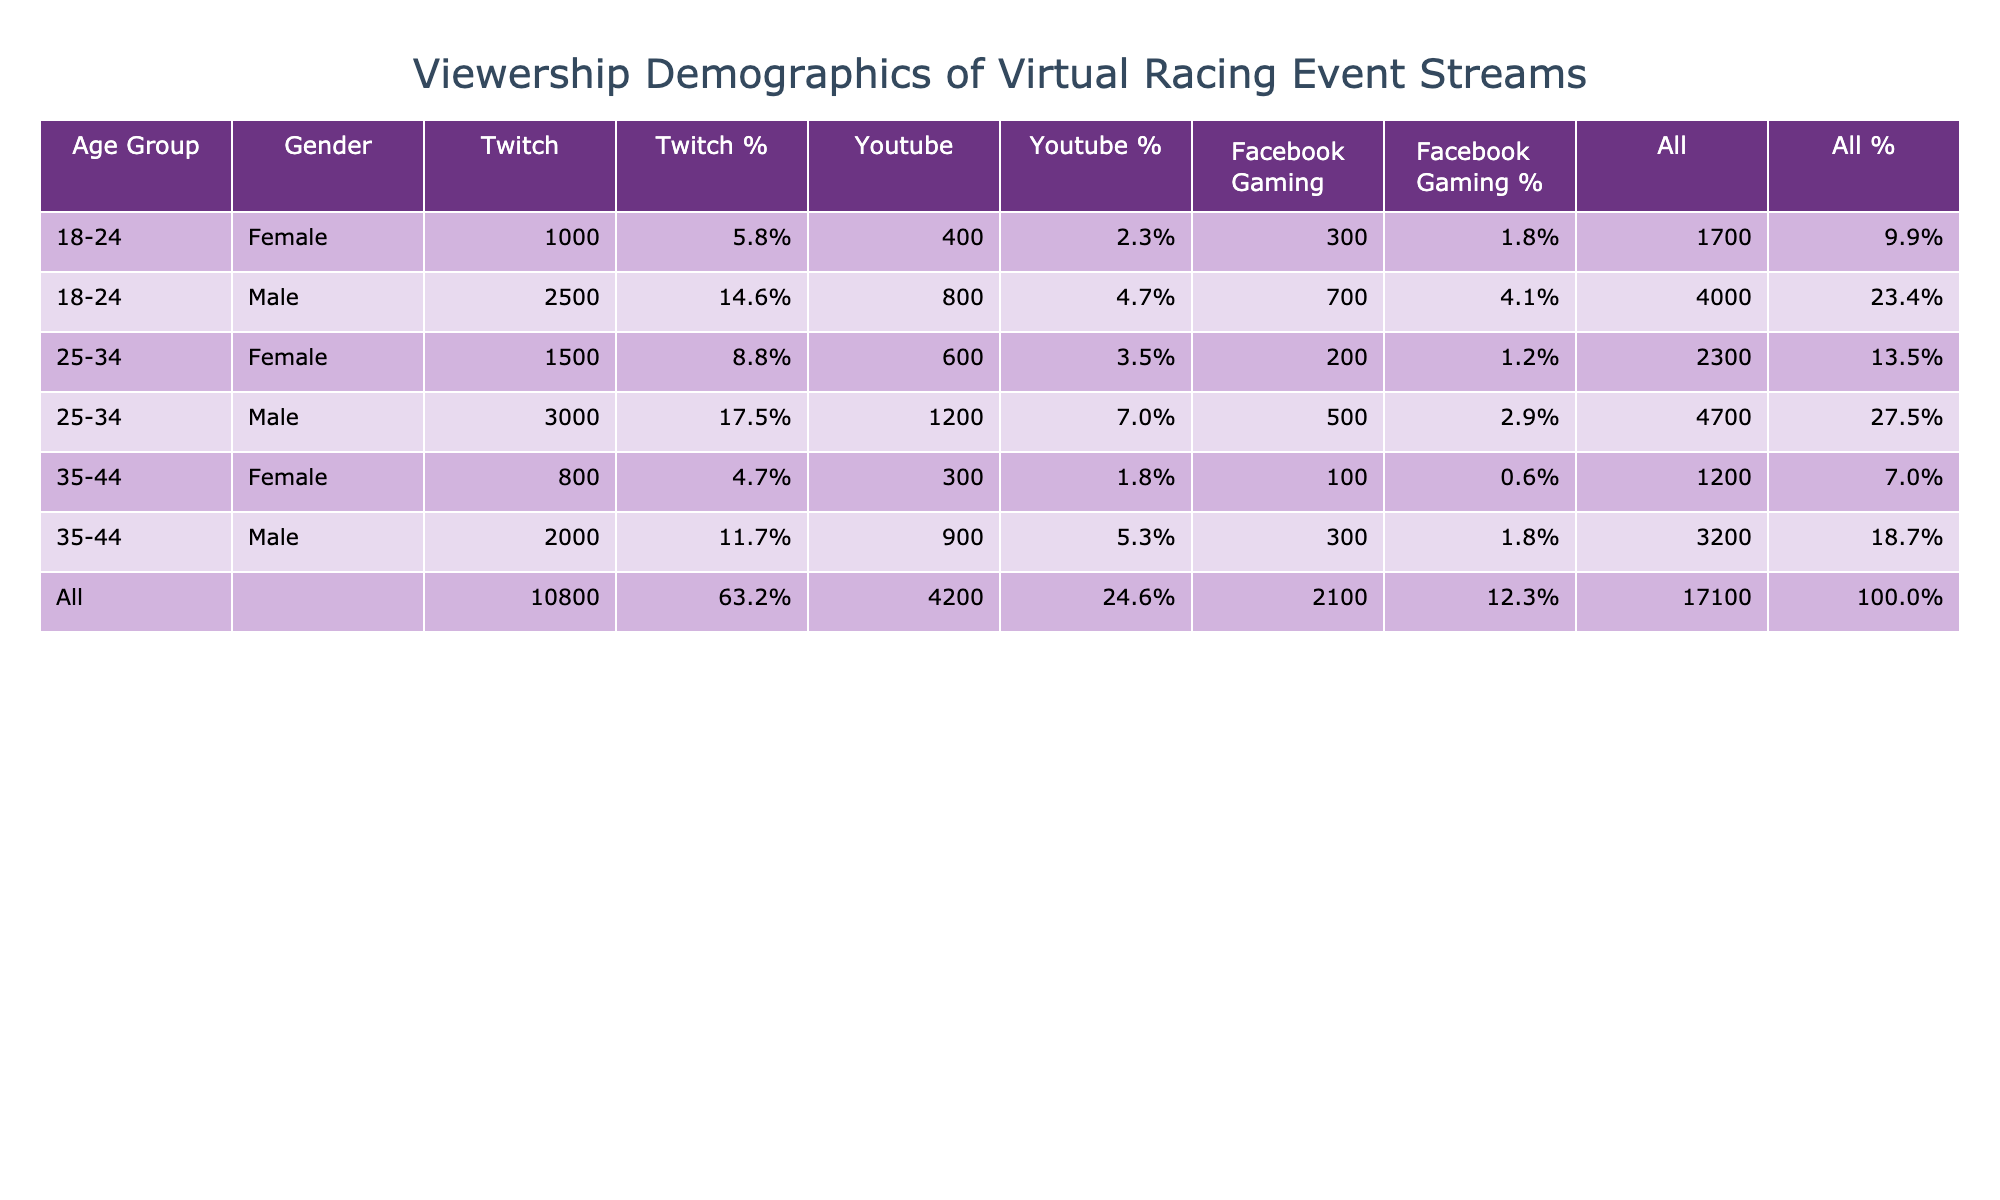What is the total viewership count for all male viewers in the age group 25-34 on Twitch? To find the total viewership count for all male viewers in the age group 25-34 on Twitch, we look at the corresponding row in the table. The value for this demographic is 3000, so the total viewership count is 3000.
Answer: 3000 Which platform has the highest viewership count for female viewers aged 35-44? We check the rows corresponding to female viewers in the age group 35-44 across all platforms. The viewership counts are 800 on Twitch, 300 on YouTube, and 100 on Facebook Gaming. The highest among these is 800 on Twitch.
Answer: 800 Is the total viewership count for male viewers across all age groups on YouTube greater than 3000? We sum the viewership counts for male viewers on YouTube: 1200 (18-24) + 3000 (25-34) + 900 (35-44) = 5100. Since 5100 is greater than 3000, the answer is yes.
Answer: Yes What is the percentage of viewership for male viewers aged 18-24 on Facebook Gaming? The total viewership count from the table for this demographic on Facebook Gaming is 700. The total viewership across all demographics is calculated as 2500 + 1000 + 3000 + 1500 + 2000 + 800 + 800 + 400 + 1200 + 600 + 900 + 300 + 700 + 300 + 500 + 200 + 300 + 100 = 15300. The percentage is (700/15300) * 100, which equals approximately 4.6%.
Answer: 4.6% Which age group has the lowest total viewership count for female viewers across all platforms? First, we look at the female viewership counts: 1000 (18-24) + 1500 (25-34) + 800 (35-44) on Twitch; 400 (18-24) + 600 (25-34) + 300 (35-44) on YouTube; and 300 (18-24) + 200 (25-34) + 100 (35-44) on Facebook Gaming. Adding these up gives: 1000 + 1500 + 800 = 3300 on Twitch, 400 + 600 + 300 = 1300 on YouTube, and 300 + 200 + 100 = 600 on Facebook Gaming. The age group 35-44 has the lowest count at 800 on Twitch, 300 on YouTube, and 100 on Facebook Gaming; the total is 1200, so the other age groups have higher counts.
Answer: 35-44 Are there any significant differences in viewership between Twitch and YouTube for the 25-34 male demographic? The viewership for male viewers aged 25-34 on Twitch is 3000, while on YouTube it is 1200. The difference in viewership between Twitch and YouTube is 3000 - 1200 = 1800, signifying that Twitch has significantly more viewers for this demographic.
Answer: Yes 